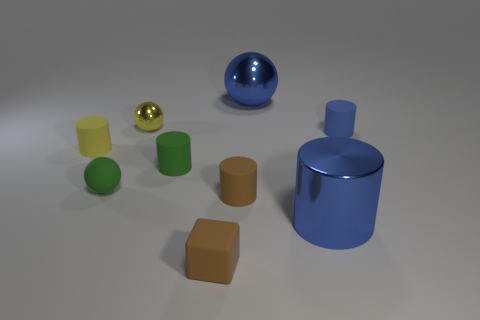Subtract 2 cylinders. How many cylinders are left? 3 Subtract all big cylinders. How many cylinders are left? 4 Subtract all yellow cylinders. How many cylinders are left? 4 Subtract all red balls. Subtract all blue cubes. How many balls are left? 3 Add 1 purple metallic cylinders. How many objects exist? 10 Subtract all spheres. How many objects are left? 6 Add 1 yellow cylinders. How many yellow cylinders exist? 2 Subtract 1 brown cubes. How many objects are left? 8 Subtract all small brown blocks. Subtract all matte cubes. How many objects are left? 7 Add 6 tiny brown rubber things. How many tiny brown rubber things are left? 8 